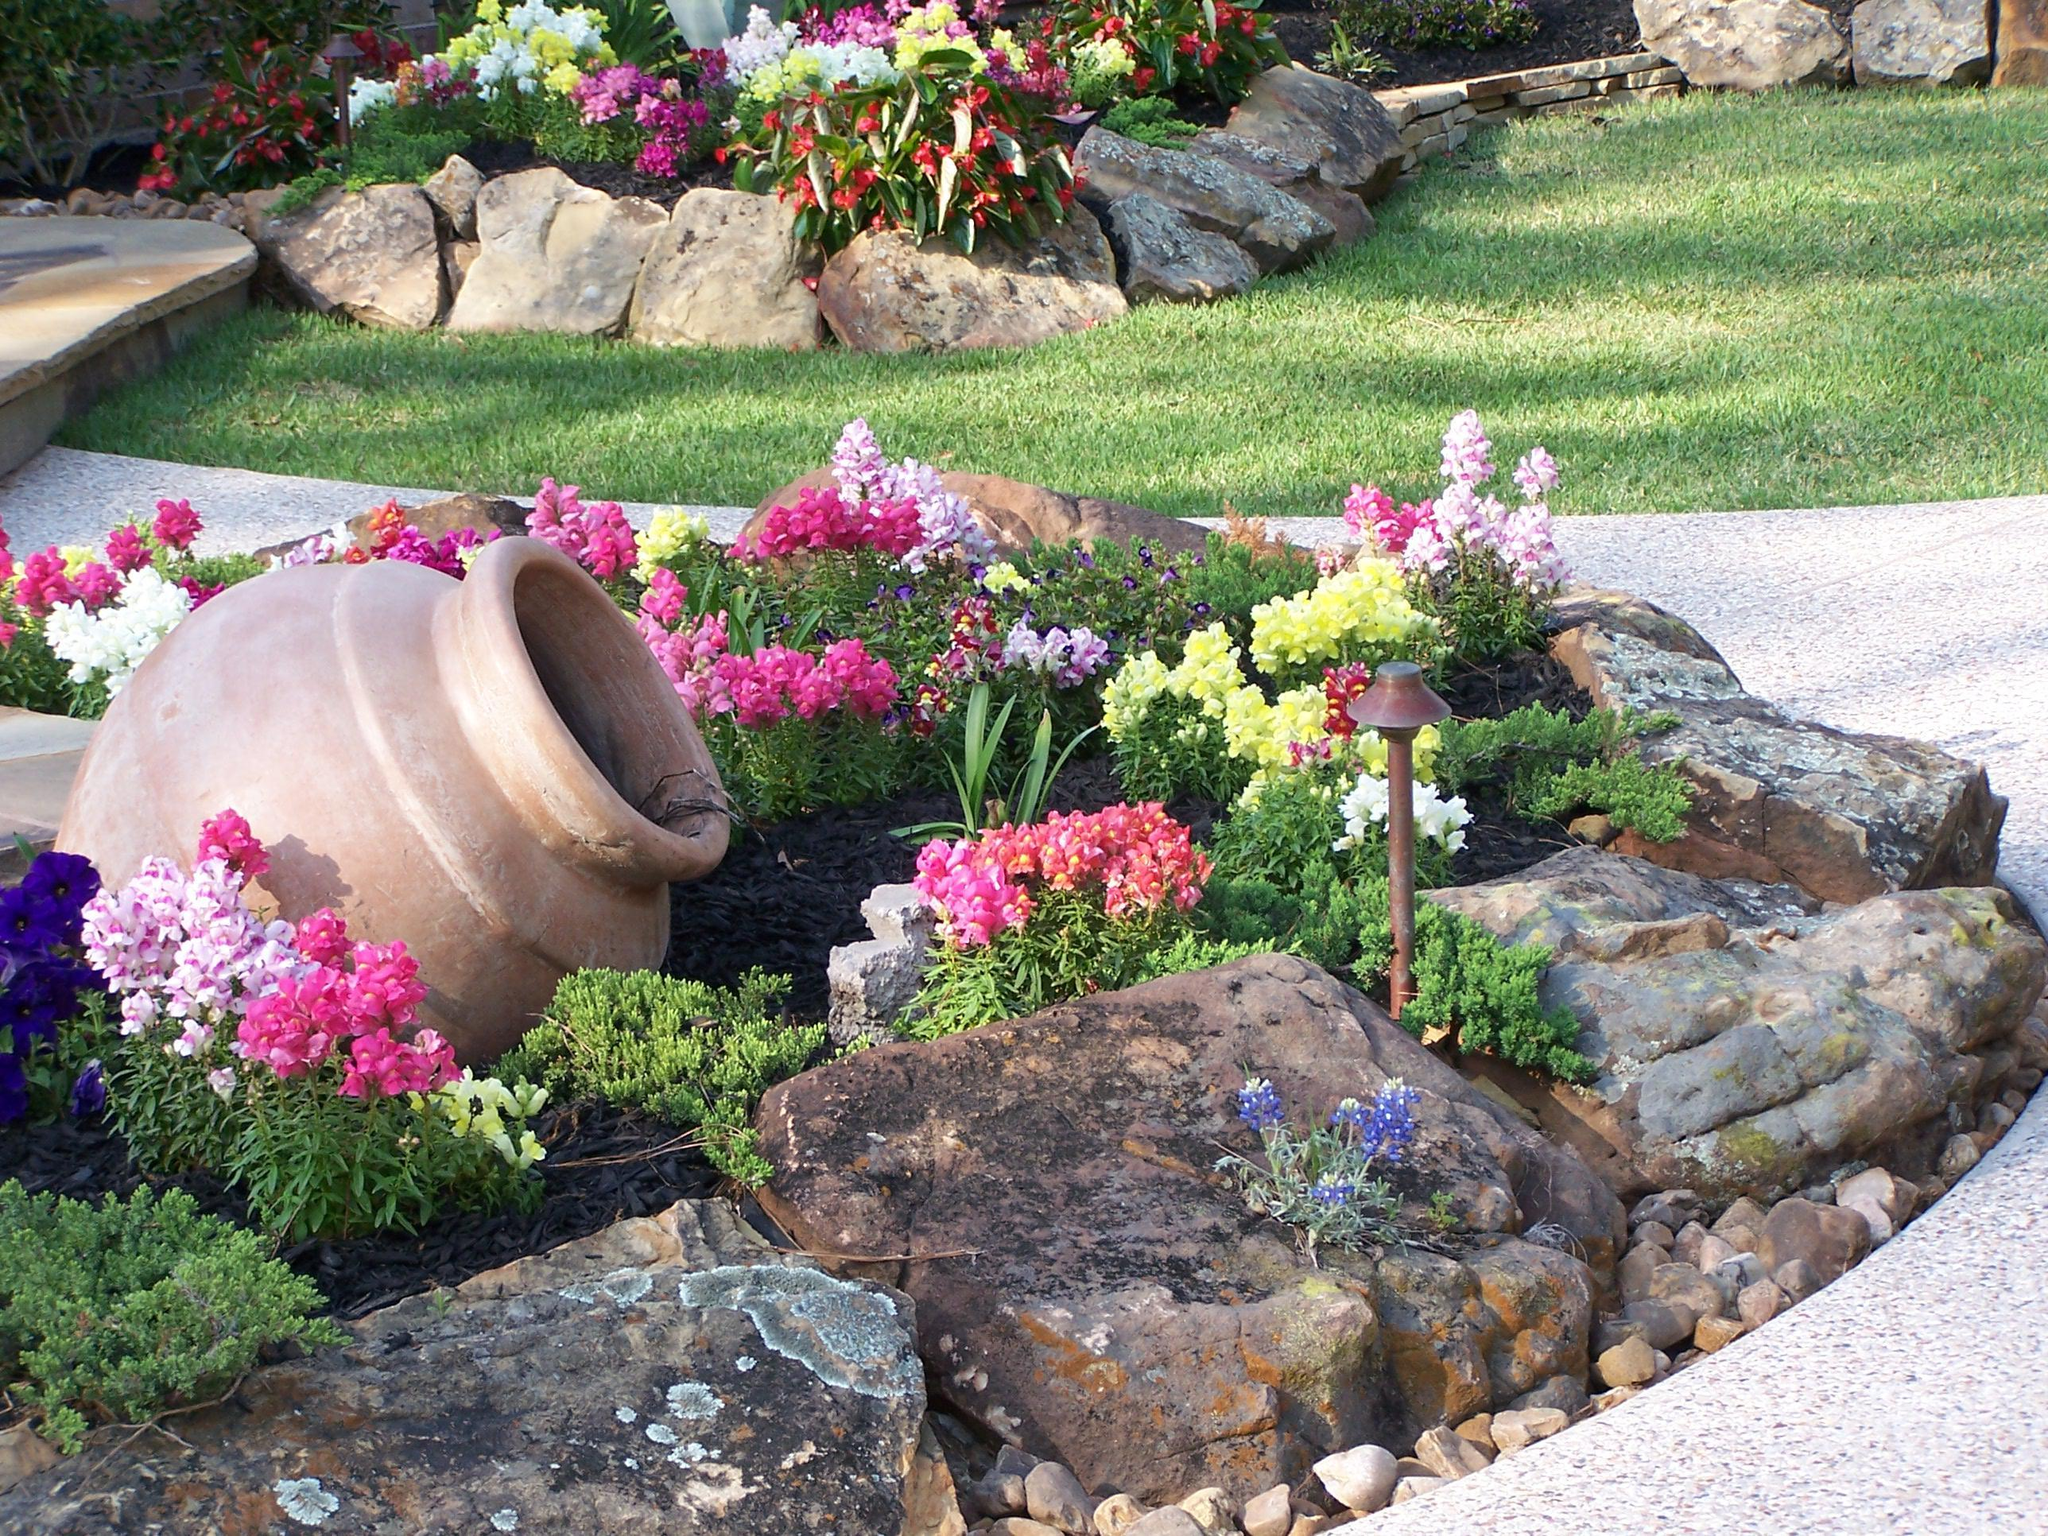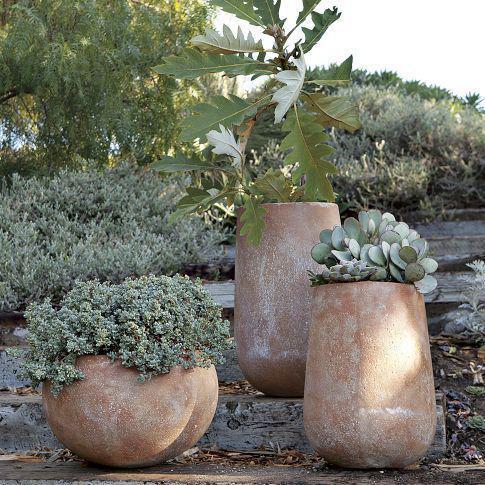The first image is the image on the left, the second image is the image on the right. Given the left and right images, does the statement "Each image features exactly one upright pottery vessel." hold true? Answer yes or no. No. The first image is the image on the left, the second image is the image on the right. Evaluate the accuracy of this statement regarding the images: "Two large urn shaped pots are placed in outdoor garden settings, with at least one being used as a water fountain.". Is it true? Answer yes or no. No. 